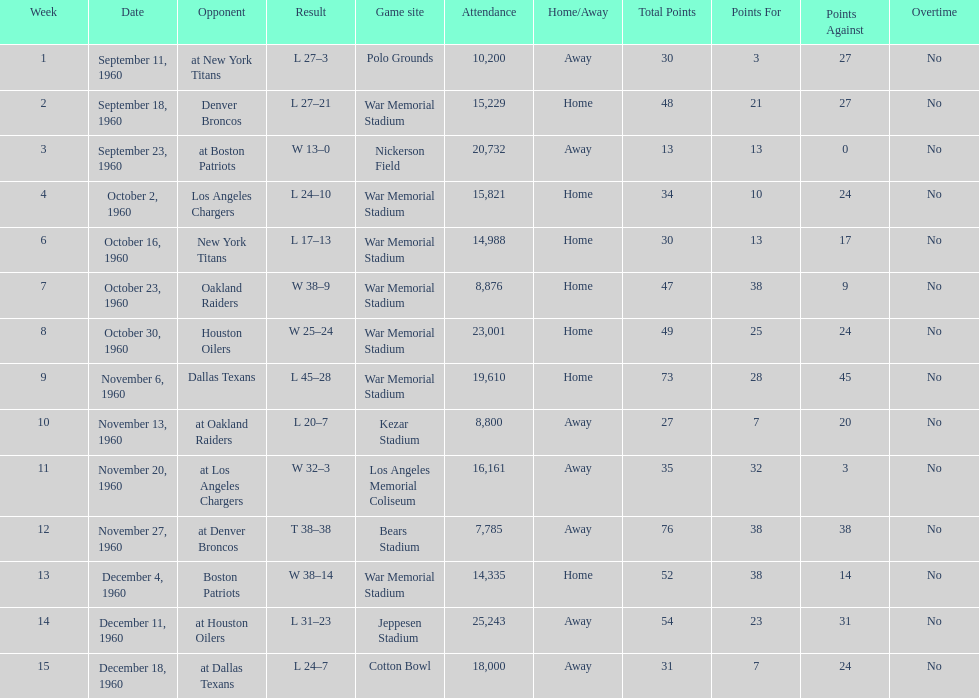What was the largest difference of points in a single game? 29. 